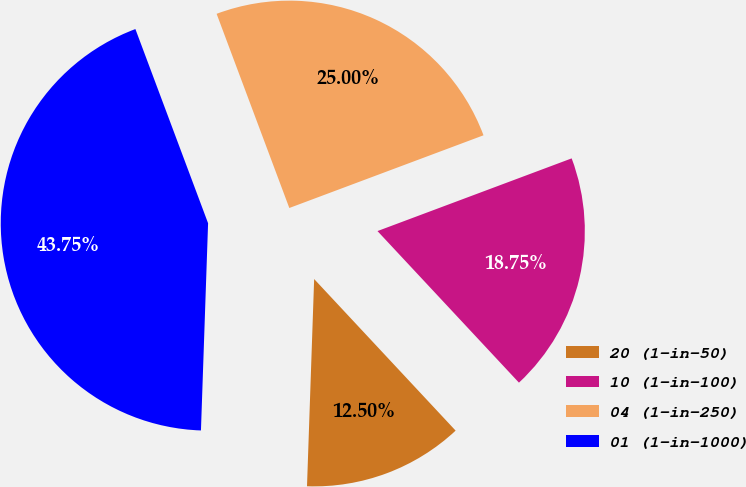<chart> <loc_0><loc_0><loc_500><loc_500><pie_chart><fcel>20 (1-in-50)<fcel>10 (1-in-100)<fcel>04 (1-in-250)<fcel>01 (1-in-1000)<nl><fcel>12.5%<fcel>18.75%<fcel>25.0%<fcel>43.75%<nl></chart> 